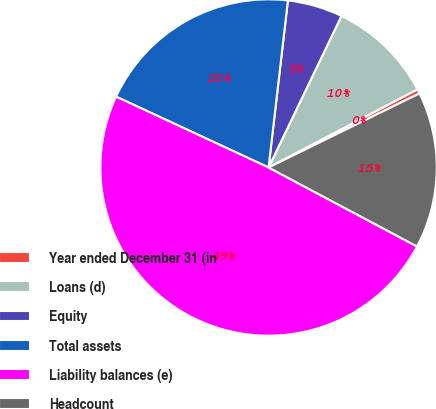Convert chart to OTSL. <chart><loc_0><loc_0><loc_500><loc_500><pie_chart><fcel>Year ended December 31 (in<fcel>Loans (d)<fcel>Equity<fcel>Total assets<fcel>Liability balances (e)<fcel>Headcount<nl><fcel>0.43%<fcel>10.17%<fcel>5.3%<fcel>19.91%<fcel>49.14%<fcel>15.04%<nl></chart> 